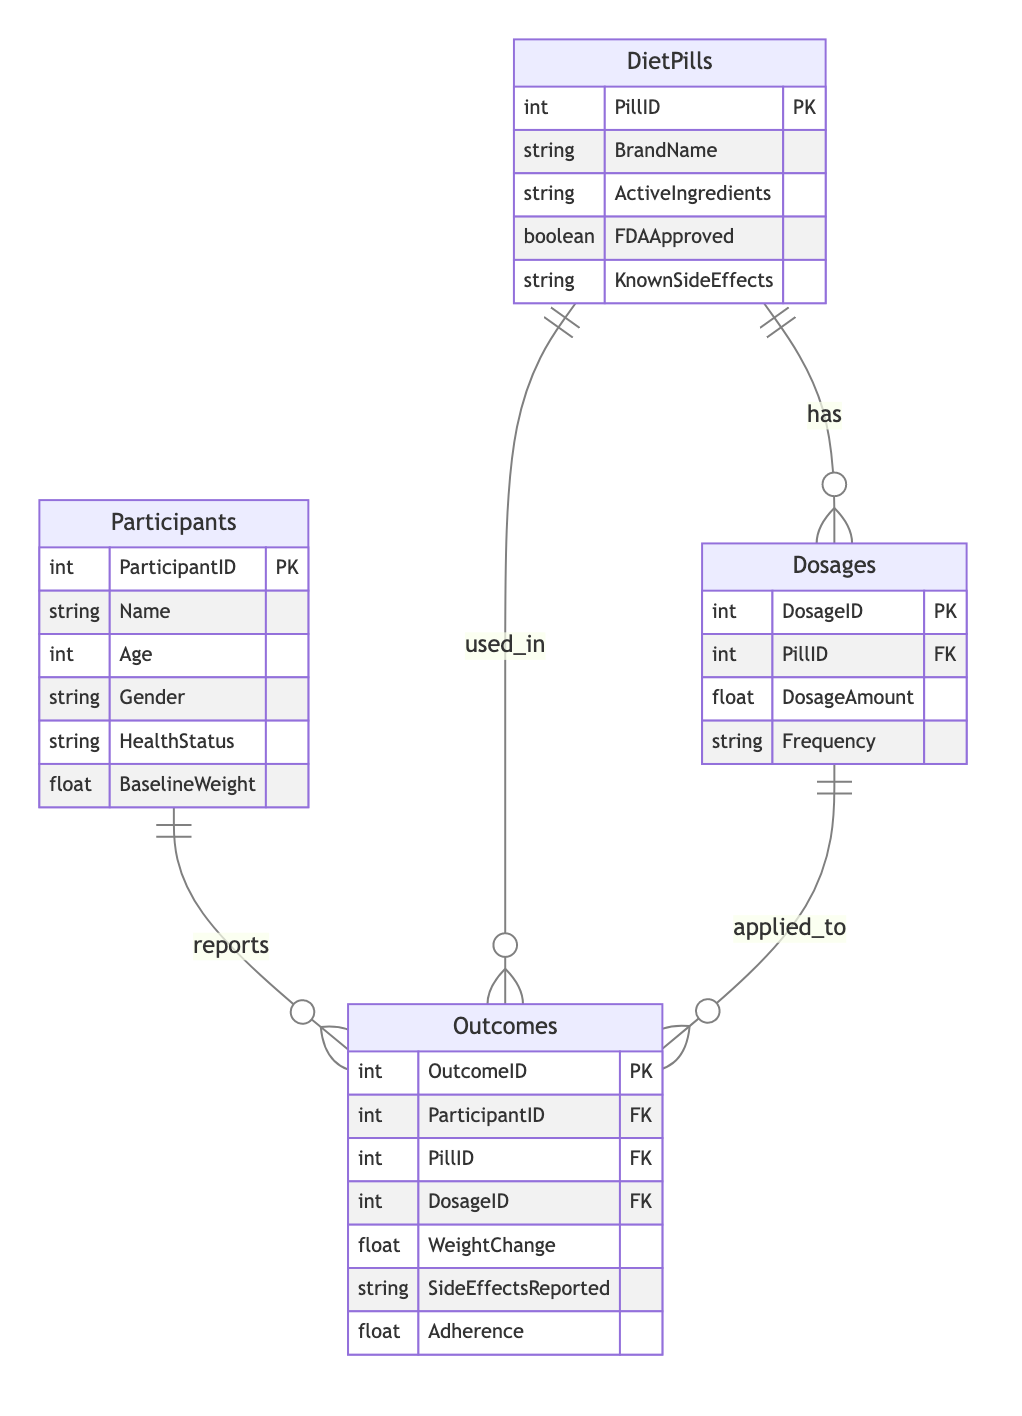What's the primary key of the Participants entity? The primary key for the Participants entity is ParticipantID, which uniquely identifies each participant in the survey.
Answer: ParticipantID How many entities are there in the diagram? The diagram consists of four entities: Participants, DietPills, Dosages, and Outcomes.
Answer: Four What relationship exists between DietPills and Outcomes? There is a one-to-many relationship between DietPills and Outcomes, indicating that each type of diet pill can be associated with multiple outcome reports from participants.
Answer: Used in How many foreign keys are in the Outcomes entity? The Outcomes entity has three foreign keys: ParticipantID, PillID, and DosageID, which link it to the Participants, DietPills, and Dosages entities, respectively.
Answer: Three What is the relationship type between Participants and Outcomes? The relationship between Participants and Outcomes is one-to-many, meaning each participant can report multiple outcomes.
Answer: One-to-many Which entity has a one-to-many relationship with Dosages? The DietPills entity has a one-to-many relationship with Dosages, indicating that each diet pill can have multiple different dosages associated with it.
Answer: DietPills In the diagram, how many attributes does the DietPills entity have? The DietPills entity has five attributes: PillID, BrandName, ActiveIngredients, FDAApproved, and KnownSideEffects.
Answer: Five Which entity contains the attribute BaselineWeight? The attribute BaselineWeight is found in the Participants entity, where it indicates the starting weight of each participant in the study.
Answer: Participants What is the foreign key in the Dosages entity? The foreign key in the Dosages entity is PillID, which connects it to the DietPills entity, linking each dosage to a specific diet pill.
Answer: PillID What does the attribute SideEffectsReported signify in the Outcomes entity? The SideEffectsReported attribute in the Outcomes entity signifies the documented side effects experienced by participants as they used the diet pills.
Answer: Side effects experienced 